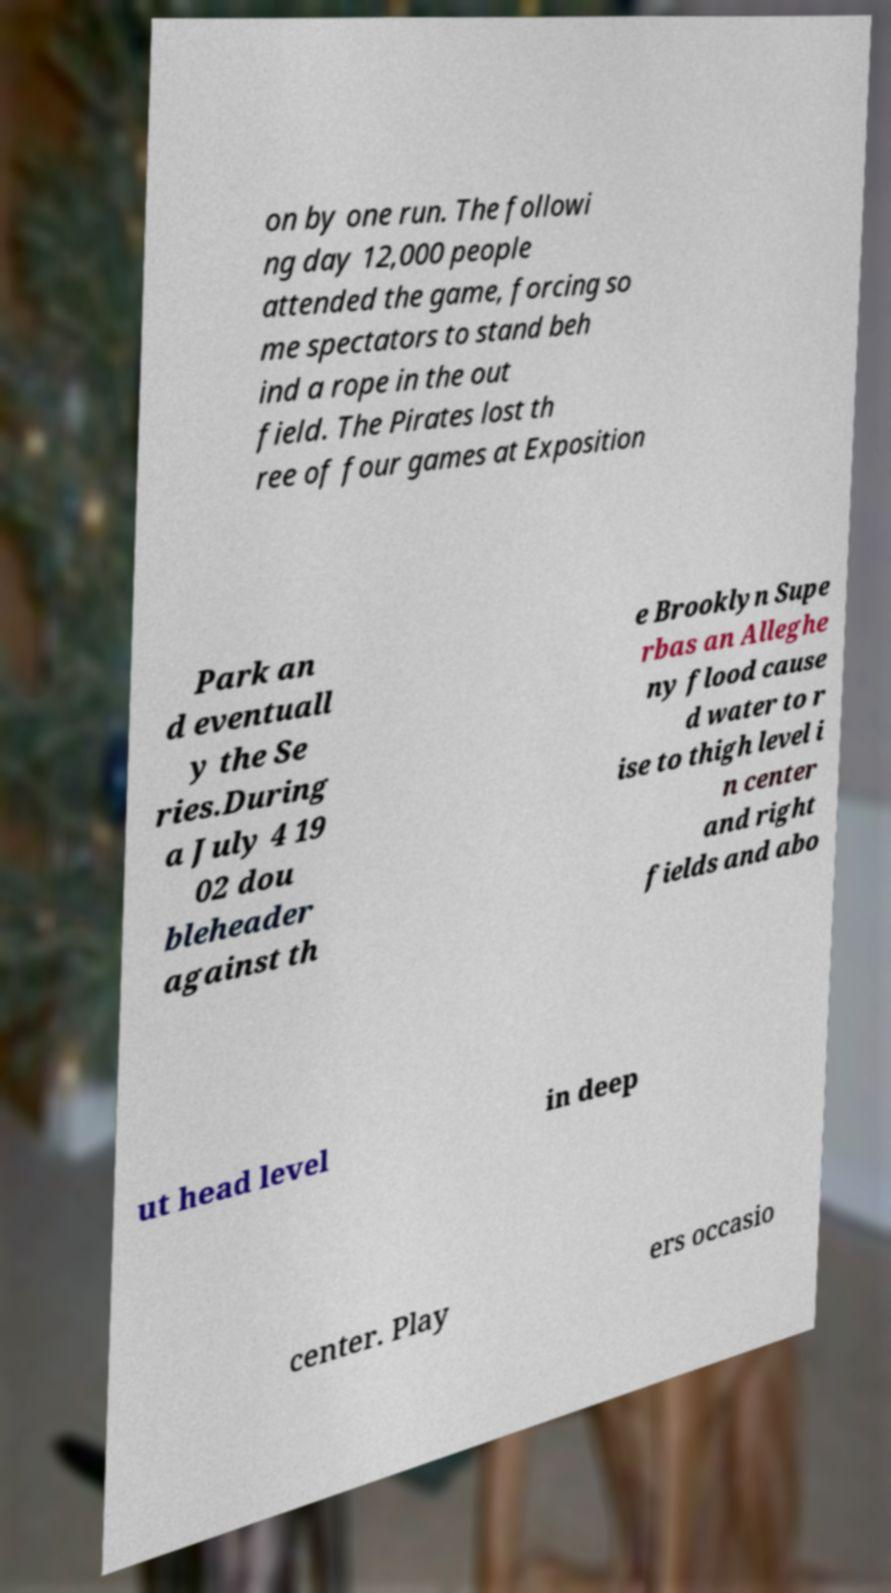For documentation purposes, I need the text within this image transcribed. Could you provide that? on by one run. The followi ng day 12,000 people attended the game, forcing so me spectators to stand beh ind a rope in the out field. The Pirates lost th ree of four games at Exposition Park an d eventuall y the Se ries.During a July 4 19 02 dou bleheader against th e Brooklyn Supe rbas an Alleghe ny flood cause d water to r ise to thigh level i n center and right fields and abo ut head level in deep center. Play ers occasio 